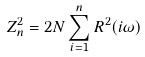Convert formula to latex. <formula><loc_0><loc_0><loc_500><loc_500>Z _ { n } ^ { 2 } = 2 N \sum _ { i = 1 } ^ { n } R ^ { 2 } ( i \omega )</formula> 